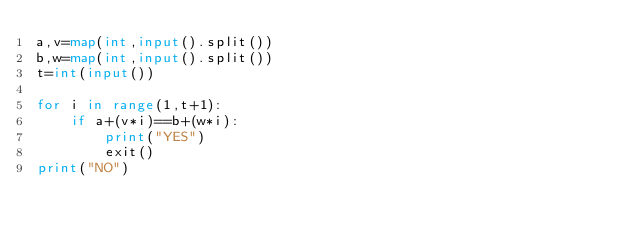<code> <loc_0><loc_0><loc_500><loc_500><_Python_>a,v=map(int,input().split())
b,w=map(int,input().split())
t=int(input())

for i in range(1,t+1):
    if a+(v*i)==b+(w*i):
        print("YES")
        exit()
print("NO")</code> 